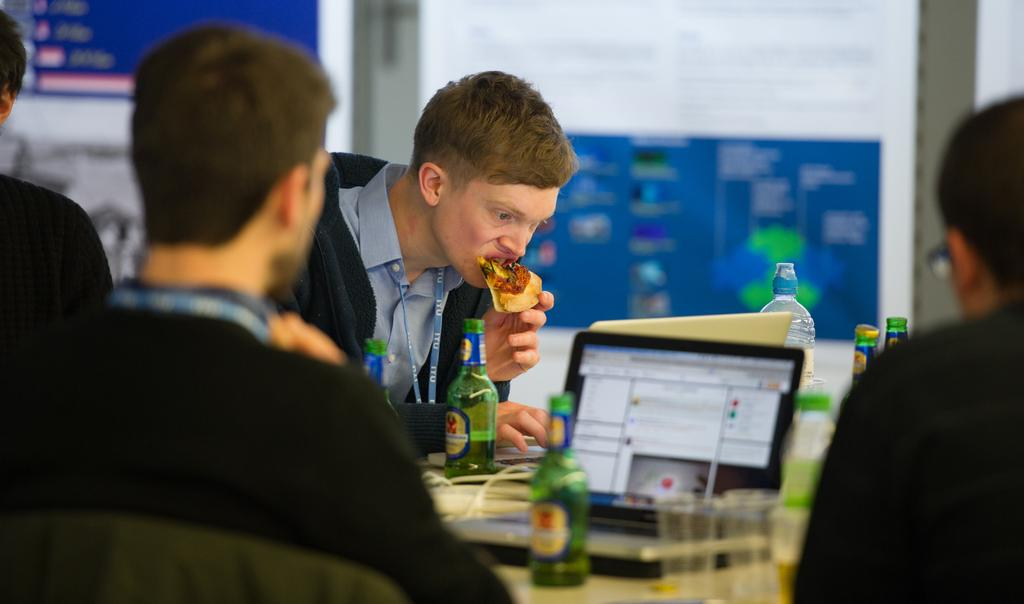How many people are in the image? There is a group of people in the image. What is one person doing with their hands? One person is holding food. What type of electronic devices can be seen in the image? There are laptops visible in the image. What type of beverage containers are present in the image? There are bottles in the image. What can be seen in the distance behind the people? There is a wall in the background of the image, and there are objects visible as well. What type of glass is being used as a table in the image? There is no glass table present in the image. Can you see any animals in the image? There are no animals visible in the image. 